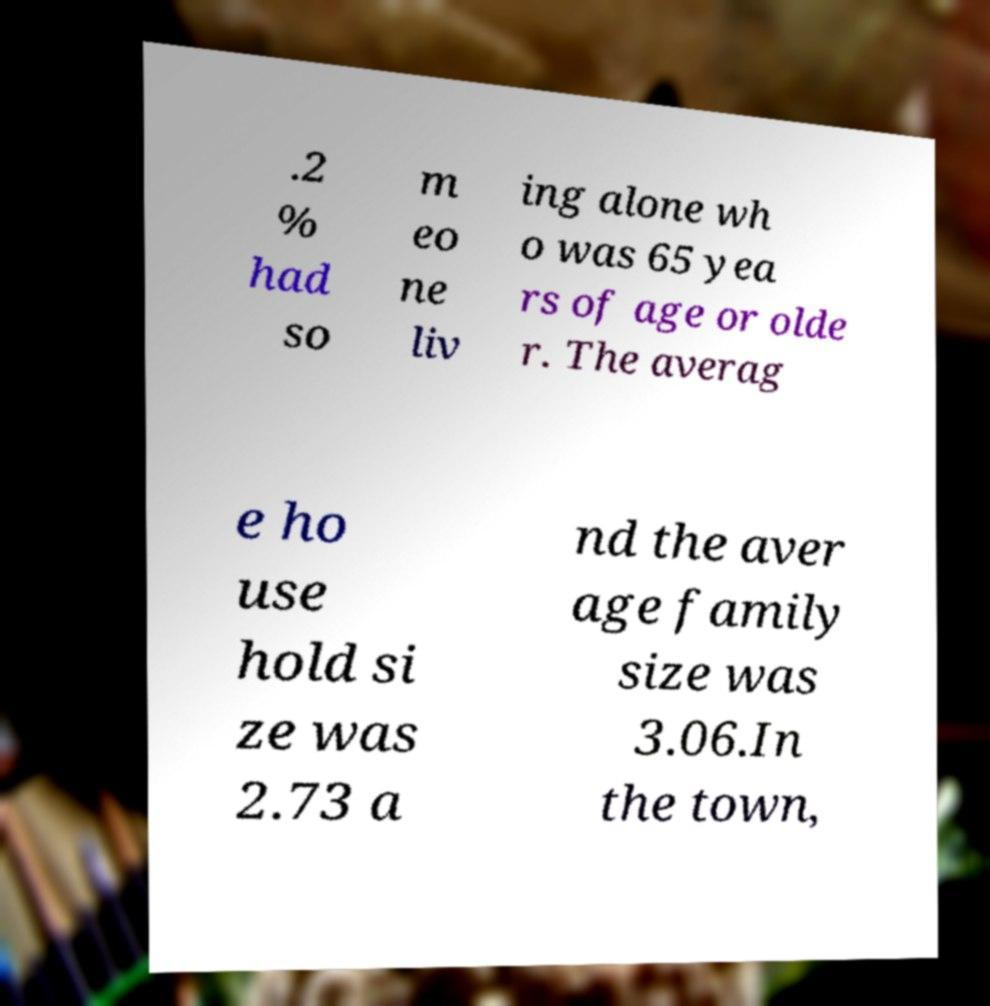What messages or text are displayed in this image? I need them in a readable, typed format. .2 % had so m eo ne liv ing alone wh o was 65 yea rs of age or olde r. The averag e ho use hold si ze was 2.73 a nd the aver age family size was 3.06.In the town, 